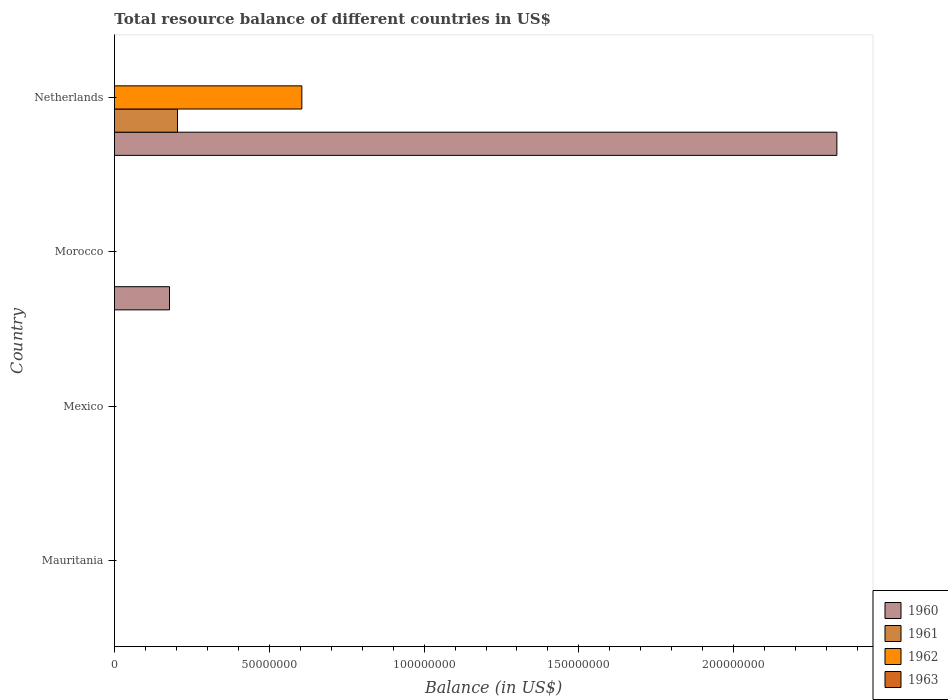How many different coloured bars are there?
Your answer should be very brief. 3. Are the number of bars per tick equal to the number of legend labels?
Give a very brief answer. No. Are the number of bars on each tick of the Y-axis equal?
Keep it short and to the point. No. What is the label of the 2nd group of bars from the top?
Keep it short and to the point. Morocco. What is the total resource balance in 1960 in Mauritania?
Your answer should be compact. 0. Across all countries, what is the maximum total resource balance in 1962?
Your response must be concise. 6.05e+07. Across all countries, what is the minimum total resource balance in 1962?
Your answer should be very brief. 0. In which country was the total resource balance in 1960 maximum?
Your answer should be very brief. Netherlands. What is the average total resource balance in 1961 per country?
Give a very brief answer. 5.09e+06. What is the difference between the total resource balance in 1962 and total resource balance in 1961 in Netherlands?
Provide a succinct answer. 4.01e+07. What is the difference between the highest and the lowest total resource balance in 1961?
Provide a short and direct response. 2.04e+07. Is it the case that in every country, the sum of the total resource balance in 1963 and total resource balance in 1962 is greater than the sum of total resource balance in 1960 and total resource balance in 1961?
Offer a very short reply. No. Is it the case that in every country, the sum of the total resource balance in 1961 and total resource balance in 1963 is greater than the total resource balance in 1960?
Your response must be concise. No. Are all the bars in the graph horizontal?
Provide a short and direct response. Yes. What is the difference between two consecutive major ticks on the X-axis?
Provide a succinct answer. 5.00e+07. Are the values on the major ticks of X-axis written in scientific E-notation?
Give a very brief answer. No. Does the graph contain grids?
Ensure brevity in your answer.  No. Where does the legend appear in the graph?
Your answer should be compact. Bottom right. How many legend labels are there?
Offer a terse response. 4. What is the title of the graph?
Keep it short and to the point. Total resource balance of different countries in US$. Does "1992" appear as one of the legend labels in the graph?
Provide a succinct answer. No. What is the label or title of the X-axis?
Offer a terse response. Balance (in US$). What is the Balance (in US$) of 1962 in Mauritania?
Provide a short and direct response. 0. What is the Balance (in US$) in 1963 in Mauritania?
Your answer should be very brief. 0. What is the Balance (in US$) of 1961 in Mexico?
Make the answer very short. 0. What is the Balance (in US$) in 1960 in Morocco?
Your response must be concise. 1.78e+07. What is the Balance (in US$) in 1961 in Morocco?
Make the answer very short. 0. What is the Balance (in US$) of 1963 in Morocco?
Your response must be concise. 0. What is the Balance (in US$) in 1960 in Netherlands?
Offer a terse response. 2.33e+08. What is the Balance (in US$) of 1961 in Netherlands?
Offer a terse response. 2.04e+07. What is the Balance (in US$) of 1962 in Netherlands?
Make the answer very short. 6.05e+07. Across all countries, what is the maximum Balance (in US$) of 1960?
Ensure brevity in your answer.  2.33e+08. Across all countries, what is the maximum Balance (in US$) of 1961?
Your response must be concise. 2.04e+07. Across all countries, what is the maximum Balance (in US$) of 1962?
Give a very brief answer. 6.05e+07. Across all countries, what is the minimum Balance (in US$) in 1960?
Your response must be concise. 0. Across all countries, what is the minimum Balance (in US$) of 1961?
Keep it short and to the point. 0. Across all countries, what is the minimum Balance (in US$) of 1962?
Give a very brief answer. 0. What is the total Balance (in US$) in 1960 in the graph?
Your answer should be compact. 2.51e+08. What is the total Balance (in US$) in 1961 in the graph?
Make the answer very short. 2.04e+07. What is the total Balance (in US$) in 1962 in the graph?
Your response must be concise. 6.05e+07. What is the difference between the Balance (in US$) of 1960 in Morocco and that in Netherlands?
Offer a very short reply. -2.16e+08. What is the difference between the Balance (in US$) in 1960 in Morocco and the Balance (in US$) in 1961 in Netherlands?
Your answer should be very brief. -2.59e+06. What is the difference between the Balance (in US$) of 1960 in Morocco and the Balance (in US$) of 1962 in Netherlands?
Your answer should be compact. -4.27e+07. What is the average Balance (in US$) of 1960 per country?
Keep it short and to the point. 6.28e+07. What is the average Balance (in US$) in 1961 per country?
Provide a succinct answer. 5.09e+06. What is the average Balance (in US$) of 1962 per country?
Offer a terse response. 1.51e+07. What is the average Balance (in US$) of 1963 per country?
Keep it short and to the point. 0. What is the difference between the Balance (in US$) in 1960 and Balance (in US$) in 1961 in Netherlands?
Offer a terse response. 2.13e+08. What is the difference between the Balance (in US$) in 1960 and Balance (in US$) in 1962 in Netherlands?
Your response must be concise. 1.73e+08. What is the difference between the Balance (in US$) of 1961 and Balance (in US$) of 1962 in Netherlands?
Give a very brief answer. -4.01e+07. What is the ratio of the Balance (in US$) in 1960 in Morocco to that in Netherlands?
Provide a short and direct response. 0.08. What is the difference between the highest and the lowest Balance (in US$) of 1960?
Your answer should be very brief. 2.33e+08. What is the difference between the highest and the lowest Balance (in US$) of 1961?
Your answer should be very brief. 2.04e+07. What is the difference between the highest and the lowest Balance (in US$) of 1962?
Give a very brief answer. 6.05e+07. 